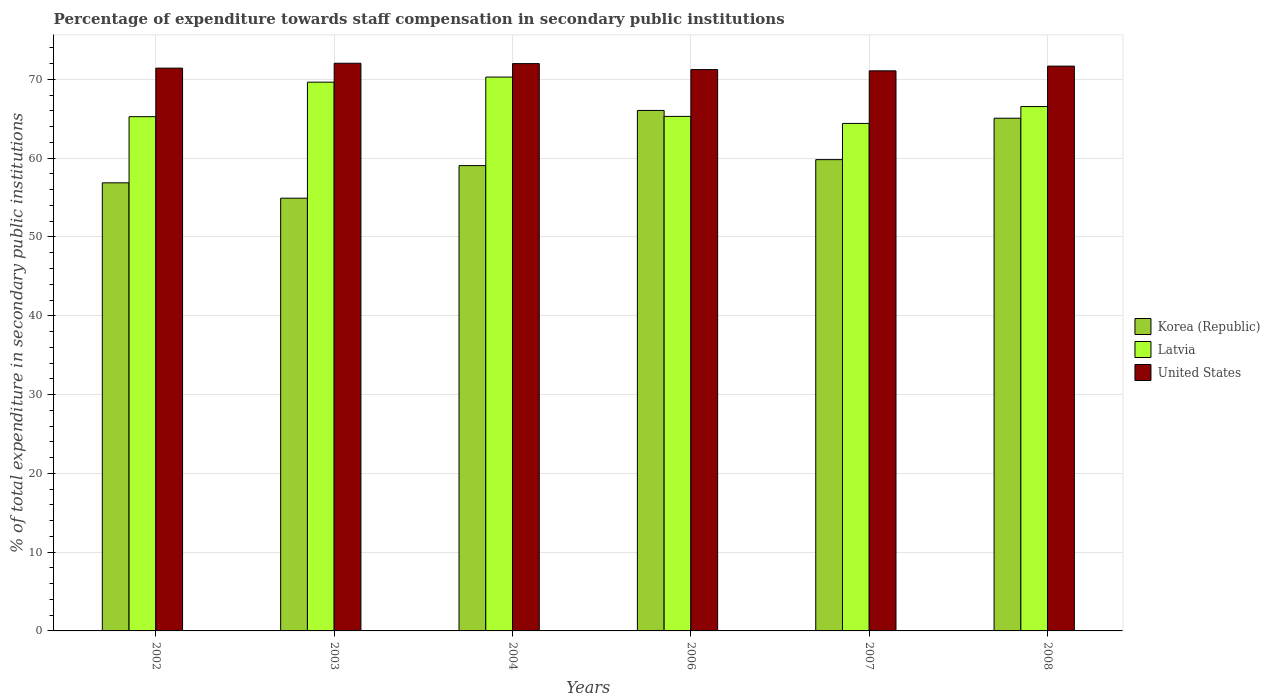How many groups of bars are there?
Provide a short and direct response. 6. Are the number of bars on each tick of the X-axis equal?
Provide a short and direct response. Yes. What is the label of the 3rd group of bars from the left?
Your answer should be very brief. 2004. What is the percentage of expenditure towards staff compensation in Latvia in 2002?
Make the answer very short. 65.27. Across all years, what is the maximum percentage of expenditure towards staff compensation in Korea (Republic)?
Your answer should be compact. 66.06. Across all years, what is the minimum percentage of expenditure towards staff compensation in Latvia?
Offer a very short reply. 64.41. What is the total percentage of expenditure towards staff compensation in Korea (Republic) in the graph?
Provide a succinct answer. 361.82. What is the difference between the percentage of expenditure towards staff compensation in Korea (Republic) in 2003 and that in 2004?
Ensure brevity in your answer.  -4.14. What is the difference between the percentage of expenditure towards staff compensation in United States in 2007 and the percentage of expenditure towards staff compensation in Latvia in 2003?
Give a very brief answer. 1.44. What is the average percentage of expenditure towards staff compensation in Latvia per year?
Provide a succinct answer. 66.92. In the year 2002, what is the difference between the percentage of expenditure towards staff compensation in Latvia and percentage of expenditure towards staff compensation in United States?
Provide a short and direct response. -6.16. What is the ratio of the percentage of expenditure towards staff compensation in Latvia in 2004 to that in 2008?
Your answer should be very brief. 1.06. Is the percentage of expenditure towards staff compensation in Latvia in 2004 less than that in 2007?
Your answer should be very brief. No. What is the difference between the highest and the second highest percentage of expenditure towards staff compensation in United States?
Provide a succinct answer. 0.04. What is the difference between the highest and the lowest percentage of expenditure towards staff compensation in Latvia?
Your response must be concise. 5.88. In how many years, is the percentage of expenditure towards staff compensation in Latvia greater than the average percentage of expenditure towards staff compensation in Latvia taken over all years?
Provide a short and direct response. 2. What does the 3rd bar from the right in 2008 represents?
Your answer should be compact. Korea (Republic). Is it the case that in every year, the sum of the percentage of expenditure towards staff compensation in United States and percentage of expenditure towards staff compensation in Korea (Republic) is greater than the percentage of expenditure towards staff compensation in Latvia?
Keep it short and to the point. Yes. Are the values on the major ticks of Y-axis written in scientific E-notation?
Your response must be concise. No. How many legend labels are there?
Your response must be concise. 3. How are the legend labels stacked?
Your response must be concise. Vertical. What is the title of the graph?
Your response must be concise. Percentage of expenditure towards staff compensation in secondary public institutions. Does "China" appear as one of the legend labels in the graph?
Offer a terse response. No. What is the label or title of the Y-axis?
Your response must be concise. % of total expenditure in secondary public institutions. What is the % of total expenditure in secondary public institutions in Korea (Republic) in 2002?
Keep it short and to the point. 56.87. What is the % of total expenditure in secondary public institutions of Latvia in 2002?
Provide a succinct answer. 65.27. What is the % of total expenditure in secondary public institutions in United States in 2002?
Provide a short and direct response. 71.43. What is the % of total expenditure in secondary public institutions in Korea (Republic) in 2003?
Keep it short and to the point. 54.92. What is the % of total expenditure in secondary public institutions of Latvia in 2003?
Provide a succinct answer. 69.65. What is the % of total expenditure in secondary public institutions in United States in 2003?
Make the answer very short. 72.05. What is the % of total expenditure in secondary public institutions of Korea (Republic) in 2004?
Provide a short and direct response. 59.06. What is the % of total expenditure in secondary public institutions in Latvia in 2004?
Your answer should be compact. 70.3. What is the % of total expenditure in secondary public institutions of United States in 2004?
Your answer should be compact. 72.01. What is the % of total expenditure in secondary public institutions of Korea (Republic) in 2006?
Ensure brevity in your answer.  66.06. What is the % of total expenditure in secondary public institutions in Latvia in 2006?
Your answer should be very brief. 65.31. What is the % of total expenditure in secondary public institutions of United States in 2006?
Your response must be concise. 71.25. What is the % of total expenditure in secondary public institutions of Korea (Republic) in 2007?
Offer a terse response. 59.82. What is the % of total expenditure in secondary public institutions of Latvia in 2007?
Your answer should be compact. 64.41. What is the % of total expenditure in secondary public institutions of United States in 2007?
Provide a succinct answer. 71.09. What is the % of total expenditure in secondary public institutions of Korea (Republic) in 2008?
Provide a succinct answer. 65.08. What is the % of total expenditure in secondary public institutions in Latvia in 2008?
Provide a succinct answer. 66.56. What is the % of total expenditure in secondary public institutions in United States in 2008?
Give a very brief answer. 71.69. Across all years, what is the maximum % of total expenditure in secondary public institutions in Korea (Republic)?
Provide a succinct answer. 66.06. Across all years, what is the maximum % of total expenditure in secondary public institutions in Latvia?
Keep it short and to the point. 70.3. Across all years, what is the maximum % of total expenditure in secondary public institutions of United States?
Offer a very short reply. 72.05. Across all years, what is the minimum % of total expenditure in secondary public institutions in Korea (Republic)?
Provide a short and direct response. 54.92. Across all years, what is the minimum % of total expenditure in secondary public institutions of Latvia?
Provide a succinct answer. 64.41. Across all years, what is the minimum % of total expenditure in secondary public institutions of United States?
Offer a terse response. 71.09. What is the total % of total expenditure in secondary public institutions in Korea (Republic) in the graph?
Your response must be concise. 361.82. What is the total % of total expenditure in secondary public institutions of Latvia in the graph?
Your answer should be compact. 401.49. What is the total % of total expenditure in secondary public institutions in United States in the graph?
Your response must be concise. 429.51. What is the difference between the % of total expenditure in secondary public institutions in Korea (Republic) in 2002 and that in 2003?
Ensure brevity in your answer.  1.95. What is the difference between the % of total expenditure in secondary public institutions of Latvia in 2002 and that in 2003?
Make the answer very short. -4.38. What is the difference between the % of total expenditure in secondary public institutions of United States in 2002 and that in 2003?
Offer a terse response. -0.62. What is the difference between the % of total expenditure in secondary public institutions in Korea (Republic) in 2002 and that in 2004?
Give a very brief answer. -2.19. What is the difference between the % of total expenditure in secondary public institutions in Latvia in 2002 and that in 2004?
Offer a terse response. -5.03. What is the difference between the % of total expenditure in secondary public institutions of United States in 2002 and that in 2004?
Keep it short and to the point. -0.57. What is the difference between the % of total expenditure in secondary public institutions of Korea (Republic) in 2002 and that in 2006?
Your answer should be very brief. -9.19. What is the difference between the % of total expenditure in secondary public institutions of Latvia in 2002 and that in 2006?
Your response must be concise. -0.04. What is the difference between the % of total expenditure in secondary public institutions in United States in 2002 and that in 2006?
Provide a short and direct response. 0.18. What is the difference between the % of total expenditure in secondary public institutions of Korea (Republic) in 2002 and that in 2007?
Your answer should be compact. -2.94. What is the difference between the % of total expenditure in secondary public institutions of Latvia in 2002 and that in 2007?
Give a very brief answer. 0.86. What is the difference between the % of total expenditure in secondary public institutions of United States in 2002 and that in 2007?
Give a very brief answer. 0.34. What is the difference between the % of total expenditure in secondary public institutions of Korea (Republic) in 2002 and that in 2008?
Make the answer very short. -8.2. What is the difference between the % of total expenditure in secondary public institutions in Latvia in 2002 and that in 2008?
Keep it short and to the point. -1.29. What is the difference between the % of total expenditure in secondary public institutions in United States in 2002 and that in 2008?
Your answer should be compact. -0.26. What is the difference between the % of total expenditure in secondary public institutions of Korea (Republic) in 2003 and that in 2004?
Keep it short and to the point. -4.14. What is the difference between the % of total expenditure in secondary public institutions of Latvia in 2003 and that in 2004?
Give a very brief answer. -0.64. What is the difference between the % of total expenditure in secondary public institutions of United States in 2003 and that in 2004?
Your response must be concise. 0.04. What is the difference between the % of total expenditure in secondary public institutions of Korea (Republic) in 2003 and that in 2006?
Your answer should be very brief. -11.14. What is the difference between the % of total expenditure in secondary public institutions of Latvia in 2003 and that in 2006?
Offer a terse response. 4.35. What is the difference between the % of total expenditure in secondary public institutions of United States in 2003 and that in 2006?
Your answer should be compact. 0.8. What is the difference between the % of total expenditure in secondary public institutions of Korea (Republic) in 2003 and that in 2007?
Your answer should be very brief. -4.89. What is the difference between the % of total expenditure in secondary public institutions in Latvia in 2003 and that in 2007?
Make the answer very short. 5.24. What is the difference between the % of total expenditure in secondary public institutions of United States in 2003 and that in 2007?
Offer a terse response. 0.96. What is the difference between the % of total expenditure in secondary public institutions of Korea (Republic) in 2003 and that in 2008?
Your response must be concise. -10.15. What is the difference between the % of total expenditure in secondary public institutions in Latvia in 2003 and that in 2008?
Ensure brevity in your answer.  3.1. What is the difference between the % of total expenditure in secondary public institutions of United States in 2003 and that in 2008?
Your response must be concise. 0.36. What is the difference between the % of total expenditure in secondary public institutions of Korea (Republic) in 2004 and that in 2006?
Provide a short and direct response. -7. What is the difference between the % of total expenditure in secondary public institutions in Latvia in 2004 and that in 2006?
Make the answer very short. 4.99. What is the difference between the % of total expenditure in secondary public institutions in United States in 2004 and that in 2006?
Make the answer very short. 0.76. What is the difference between the % of total expenditure in secondary public institutions of Korea (Republic) in 2004 and that in 2007?
Ensure brevity in your answer.  -0.76. What is the difference between the % of total expenditure in secondary public institutions of Latvia in 2004 and that in 2007?
Your answer should be compact. 5.88. What is the difference between the % of total expenditure in secondary public institutions of United States in 2004 and that in 2007?
Ensure brevity in your answer.  0.92. What is the difference between the % of total expenditure in secondary public institutions of Korea (Republic) in 2004 and that in 2008?
Your response must be concise. -6.02. What is the difference between the % of total expenditure in secondary public institutions of Latvia in 2004 and that in 2008?
Give a very brief answer. 3.74. What is the difference between the % of total expenditure in secondary public institutions in United States in 2004 and that in 2008?
Provide a short and direct response. 0.32. What is the difference between the % of total expenditure in secondary public institutions of Korea (Republic) in 2006 and that in 2007?
Ensure brevity in your answer.  6.24. What is the difference between the % of total expenditure in secondary public institutions of Latvia in 2006 and that in 2007?
Your response must be concise. 0.89. What is the difference between the % of total expenditure in secondary public institutions in United States in 2006 and that in 2007?
Your response must be concise. 0.16. What is the difference between the % of total expenditure in secondary public institutions of Korea (Republic) in 2006 and that in 2008?
Your answer should be compact. 0.98. What is the difference between the % of total expenditure in secondary public institutions in Latvia in 2006 and that in 2008?
Ensure brevity in your answer.  -1.25. What is the difference between the % of total expenditure in secondary public institutions of United States in 2006 and that in 2008?
Keep it short and to the point. -0.44. What is the difference between the % of total expenditure in secondary public institutions in Korea (Republic) in 2007 and that in 2008?
Ensure brevity in your answer.  -5.26. What is the difference between the % of total expenditure in secondary public institutions in Latvia in 2007 and that in 2008?
Provide a succinct answer. -2.14. What is the difference between the % of total expenditure in secondary public institutions of United States in 2007 and that in 2008?
Offer a very short reply. -0.6. What is the difference between the % of total expenditure in secondary public institutions of Korea (Republic) in 2002 and the % of total expenditure in secondary public institutions of Latvia in 2003?
Offer a terse response. -12.78. What is the difference between the % of total expenditure in secondary public institutions in Korea (Republic) in 2002 and the % of total expenditure in secondary public institutions in United States in 2003?
Make the answer very short. -15.18. What is the difference between the % of total expenditure in secondary public institutions of Latvia in 2002 and the % of total expenditure in secondary public institutions of United States in 2003?
Provide a short and direct response. -6.78. What is the difference between the % of total expenditure in secondary public institutions in Korea (Republic) in 2002 and the % of total expenditure in secondary public institutions in Latvia in 2004?
Keep it short and to the point. -13.42. What is the difference between the % of total expenditure in secondary public institutions in Korea (Republic) in 2002 and the % of total expenditure in secondary public institutions in United States in 2004?
Make the answer very short. -15.13. What is the difference between the % of total expenditure in secondary public institutions in Latvia in 2002 and the % of total expenditure in secondary public institutions in United States in 2004?
Keep it short and to the point. -6.74. What is the difference between the % of total expenditure in secondary public institutions in Korea (Republic) in 2002 and the % of total expenditure in secondary public institutions in Latvia in 2006?
Offer a terse response. -8.43. What is the difference between the % of total expenditure in secondary public institutions in Korea (Republic) in 2002 and the % of total expenditure in secondary public institutions in United States in 2006?
Make the answer very short. -14.37. What is the difference between the % of total expenditure in secondary public institutions in Latvia in 2002 and the % of total expenditure in secondary public institutions in United States in 2006?
Keep it short and to the point. -5.98. What is the difference between the % of total expenditure in secondary public institutions of Korea (Republic) in 2002 and the % of total expenditure in secondary public institutions of Latvia in 2007?
Keep it short and to the point. -7.54. What is the difference between the % of total expenditure in secondary public institutions of Korea (Republic) in 2002 and the % of total expenditure in secondary public institutions of United States in 2007?
Provide a succinct answer. -14.21. What is the difference between the % of total expenditure in secondary public institutions of Latvia in 2002 and the % of total expenditure in secondary public institutions of United States in 2007?
Your answer should be very brief. -5.82. What is the difference between the % of total expenditure in secondary public institutions in Korea (Republic) in 2002 and the % of total expenditure in secondary public institutions in Latvia in 2008?
Offer a very short reply. -9.68. What is the difference between the % of total expenditure in secondary public institutions in Korea (Republic) in 2002 and the % of total expenditure in secondary public institutions in United States in 2008?
Your answer should be compact. -14.81. What is the difference between the % of total expenditure in secondary public institutions in Latvia in 2002 and the % of total expenditure in secondary public institutions in United States in 2008?
Keep it short and to the point. -6.42. What is the difference between the % of total expenditure in secondary public institutions of Korea (Republic) in 2003 and the % of total expenditure in secondary public institutions of Latvia in 2004?
Offer a terse response. -15.37. What is the difference between the % of total expenditure in secondary public institutions of Korea (Republic) in 2003 and the % of total expenditure in secondary public institutions of United States in 2004?
Keep it short and to the point. -17.08. What is the difference between the % of total expenditure in secondary public institutions in Latvia in 2003 and the % of total expenditure in secondary public institutions in United States in 2004?
Your response must be concise. -2.35. What is the difference between the % of total expenditure in secondary public institutions in Korea (Republic) in 2003 and the % of total expenditure in secondary public institutions in Latvia in 2006?
Your answer should be very brief. -10.38. What is the difference between the % of total expenditure in secondary public institutions in Korea (Republic) in 2003 and the % of total expenditure in secondary public institutions in United States in 2006?
Your response must be concise. -16.32. What is the difference between the % of total expenditure in secondary public institutions in Latvia in 2003 and the % of total expenditure in secondary public institutions in United States in 2006?
Make the answer very short. -1.59. What is the difference between the % of total expenditure in secondary public institutions in Korea (Republic) in 2003 and the % of total expenditure in secondary public institutions in Latvia in 2007?
Provide a succinct answer. -9.49. What is the difference between the % of total expenditure in secondary public institutions in Korea (Republic) in 2003 and the % of total expenditure in secondary public institutions in United States in 2007?
Offer a terse response. -16.16. What is the difference between the % of total expenditure in secondary public institutions of Latvia in 2003 and the % of total expenditure in secondary public institutions of United States in 2007?
Offer a very short reply. -1.44. What is the difference between the % of total expenditure in secondary public institutions of Korea (Republic) in 2003 and the % of total expenditure in secondary public institutions of Latvia in 2008?
Make the answer very short. -11.63. What is the difference between the % of total expenditure in secondary public institutions of Korea (Republic) in 2003 and the % of total expenditure in secondary public institutions of United States in 2008?
Your response must be concise. -16.76. What is the difference between the % of total expenditure in secondary public institutions in Latvia in 2003 and the % of total expenditure in secondary public institutions in United States in 2008?
Offer a very short reply. -2.04. What is the difference between the % of total expenditure in secondary public institutions in Korea (Republic) in 2004 and the % of total expenditure in secondary public institutions in Latvia in 2006?
Keep it short and to the point. -6.25. What is the difference between the % of total expenditure in secondary public institutions in Korea (Republic) in 2004 and the % of total expenditure in secondary public institutions in United States in 2006?
Offer a terse response. -12.19. What is the difference between the % of total expenditure in secondary public institutions of Latvia in 2004 and the % of total expenditure in secondary public institutions of United States in 2006?
Provide a succinct answer. -0.95. What is the difference between the % of total expenditure in secondary public institutions in Korea (Republic) in 2004 and the % of total expenditure in secondary public institutions in Latvia in 2007?
Keep it short and to the point. -5.35. What is the difference between the % of total expenditure in secondary public institutions in Korea (Republic) in 2004 and the % of total expenditure in secondary public institutions in United States in 2007?
Make the answer very short. -12.03. What is the difference between the % of total expenditure in secondary public institutions of Latvia in 2004 and the % of total expenditure in secondary public institutions of United States in 2007?
Offer a terse response. -0.79. What is the difference between the % of total expenditure in secondary public institutions in Korea (Republic) in 2004 and the % of total expenditure in secondary public institutions in Latvia in 2008?
Provide a short and direct response. -7.49. What is the difference between the % of total expenditure in secondary public institutions of Korea (Republic) in 2004 and the % of total expenditure in secondary public institutions of United States in 2008?
Offer a terse response. -12.63. What is the difference between the % of total expenditure in secondary public institutions in Latvia in 2004 and the % of total expenditure in secondary public institutions in United States in 2008?
Your response must be concise. -1.39. What is the difference between the % of total expenditure in secondary public institutions of Korea (Republic) in 2006 and the % of total expenditure in secondary public institutions of Latvia in 2007?
Ensure brevity in your answer.  1.65. What is the difference between the % of total expenditure in secondary public institutions in Korea (Republic) in 2006 and the % of total expenditure in secondary public institutions in United States in 2007?
Provide a short and direct response. -5.03. What is the difference between the % of total expenditure in secondary public institutions of Latvia in 2006 and the % of total expenditure in secondary public institutions of United States in 2007?
Your answer should be very brief. -5.78. What is the difference between the % of total expenditure in secondary public institutions of Korea (Republic) in 2006 and the % of total expenditure in secondary public institutions of Latvia in 2008?
Provide a succinct answer. -0.49. What is the difference between the % of total expenditure in secondary public institutions of Korea (Republic) in 2006 and the % of total expenditure in secondary public institutions of United States in 2008?
Your answer should be compact. -5.63. What is the difference between the % of total expenditure in secondary public institutions in Latvia in 2006 and the % of total expenditure in secondary public institutions in United States in 2008?
Provide a short and direct response. -6.38. What is the difference between the % of total expenditure in secondary public institutions in Korea (Republic) in 2007 and the % of total expenditure in secondary public institutions in Latvia in 2008?
Make the answer very short. -6.74. What is the difference between the % of total expenditure in secondary public institutions in Korea (Republic) in 2007 and the % of total expenditure in secondary public institutions in United States in 2008?
Your answer should be very brief. -11.87. What is the difference between the % of total expenditure in secondary public institutions of Latvia in 2007 and the % of total expenditure in secondary public institutions of United States in 2008?
Your answer should be very brief. -7.27. What is the average % of total expenditure in secondary public institutions in Korea (Republic) per year?
Offer a very short reply. 60.3. What is the average % of total expenditure in secondary public institutions of Latvia per year?
Give a very brief answer. 66.92. What is the average % of total expenditure in secondary public institutions of United States per year?
Offer a very short reply. 71.59. In the year 2002, what is the difference between the % of total expenditure in secondary public institutions of Korea (Republic) and % of total expenditure in secondary public institutions of Latvia?
Your answer should be very brief. -8.39. In the year 2002, what is the difference between the % of total expenditure in secondary public institutions of Korea (Republic) and % of total expenditure in secondary public institutions of United States?
Provide a succinct answer. -14.56. In the year 2002, what is the difference between the % of total expenditure in secondary public institutions of Latvia and % of total expenditure in secondary public institutions of United States?
Make the answer very short. -6.16. In the year 2003, what is the difference between the % of total expenditure in secondary public institutions in Korea (Republic) and % of total expenditure in secondary public institutions in Latvia?
Your answer should be compact. -14.73. In the year 2003, what is the difference between the % of total expenditure in secondary public institutions of Korea (Republic) and % of total expenditure in secondary public institutions of United States?
Your response must be concise. -17.13. In the year 2003, what is the difference between the % of total expenditure in secondary public institutions of Latvia and % of total expenditure in secondary public institutions of United States?
Give a very brief answer. -2.4. In the year 2004, what is the difference between the % of total expenditure in secondary public institutions of Korea (Republic) and % of total expenditure in secondary public institutions of Latvia?
Make the answer very short. -11.24. In the year 2004, what is the difference between the % of total expenditure in secondary public institutions of Korea (Republic) and % of total expenditure in secondary public institutions of United States?
Make the answer very short. -12.95. In the year 2004, what is the difference between the % of total expenditure in secondary public institutions in Latvia and % of total expenditure in secondary public institutions in United States?
Provide a short and direct response. -1.71. In the year 2006, what is the difference between the % of total expenditure in secondary public institutions in Korea (Republic) and % of total expenditure in secondary public institutions in Latvia?
Give a very brief answer. 0.76. In the year 2006, what is the difference between the % of total expenditure in secondary public institutions in Korea (Republic) and % of total expenditure in secondary public institutions in United States?
Ensure brevity in your answer.  -5.19. In the year 2006, what is the difference between the % of total expenditure in secondary public institutions of Latvia and % of total expenditure in secondary public institutions of United States?
Your response must be concise. -5.94. In the year 2007, what is the difference between the % of total expenditure in secondary public institutions in Korea (Republic) and % of total expenditure in secondary public institutions in Latvia?
Your response must be concise. -4.59. In the year 2007, what is the difference between the % of total expenditure in secondary public institutions of Korea (Republic) and % of total expenditure in secondary public institutions of United States?
Keep it short and to the point. -11.27. In the year 2007, what is the difference between the % of total expenditure in secondary public institutions of Latvia and % of total expenditure in secondary public institutions of United States?
Provide a succinct answer. -6.67. In the year 2008, what is the difference between the % of total expenditure in secondary public institutions in Korea (Republic) and % of total expenditure in secondary public institutions in Latvia?
Provide a short and direct response. -1.48. In the year 2008, what is the difference between the % of total expenditure in secondary public institutions in Korea (Republic) and % of total expenditure in secondary public institutions in United States?
Your answer should be very brief. -6.61. In the year 2008, what is the difference between the % of total expenditure in secondary public institutions of Latvia and % of total expenditure in secondary public institutions of United States?
Keep it short and to the point. -5.13. What is the ratio of the % of total expenditure in secondary public institutions of Korea (Republic) in 2002 to that in 2003?
Your response must be concise. 1.04. What is the ratio of the % of total expenditure in secondary public institutions in Latvia in 2002 to that in 2003?
Give a very brief answer. 0.94. What is the ratio of the % of total expenditure in secondary public institutions in United States in 2002 to that in 2003?
Keep it short and to the point. 0.99. What is the ratio of the % of total expenditure in secondary public institutions of Korea (Republic) in 2002 to that in 2004?
Offer a very short reply. 0.96. What is the ratio of the % of total expenditure in secondary public institutions of Latvia in 2002 to that in 2004?
Your answer should be very brief. 0.93. What is the ratio of the % of total expenditure in secondary public institutions in United States in 2002 to that in 2004?
Offer a terse response. 0.99. What is the ratio of the % of total expenditure in secondary public institutions in Korea (Republic) in 2002 to that in 2006?
Your answer should be compact. 0.86. What is the ratio of the % of total expenditure in secondary public institutions of Korea (Republic) in 2002 to that in 2007?
Provide a succinct answer. 0.95. What is the ratio of the % of total expenditure in secondary public institutions in Latvia in 2002 to that in 2007?
Provide a short and direct response. 1.01. What is the ratio of the % of total expenditure in secondary public institutions in United States in 2002 to that in 2007?
Provide a short and direct response. 1. What is the ratio of the % of total expenditure in secondary public institutions of Korea (Republic) in 2002 to that in 2008?
Your answer should be very brief. 0.87. What is the ratio of the % of total expenditure in secondary public institutions in Latvia in 2002 to that in 2008?
Provide a succinct answer. 0.98. What is the ratio of the % of total expenditure in secondary public institutions in Korea (Republic) in 2003 to that in 2006?
Your response must be concise. 0.83. What is the ratio of the % of total expenditure in secondary public institutions in Latvia in 2003 to that in 2006?
Provide a short and direct response. 1.07. What is the ratio of the % of total expenditure in secondary public institutions of United States in 2003 to that in 2006?
Your answer should be compact. 1.01. What is the ratio of the % of total expenditure in secondary public institutions in Korea (Republic) in 2003 to that in 2007?
Give a very brief answer. 0.92. What is the ratio of the % of total expenditure in secondary public institutions in Latvia in 2003 to that in 2007?
Your answer should be compact. 1.08. What is the ratio of the % of total expenditure in secondary public institutions in United States in 2003 to that in 2007?
Offer a terse response. 1.01. What is the ratio of the % of total expenditure in secondary public institutions of Korea (Republic) in 2003 to that in 2008?
Your response must be concise. 0.84. What is the ratio of the % of total expenditure in secondary public institutions in Latvia in 2003 to that in 2008?
Provide a short and direct response. 1.05. What is the ratio of the % of total expenditure in secondary public institutions of United States in 2003 to that in 2008?
Keep it short and to the point. 1.01. What is the ratio of the % of total expenditure in secondary public institutions of Korea (Republic) in 2004 to that in 2006?
Ensure brevity in your answer.  0.89. What is the ratio of the % of total expenditure in secondary public institutions of Latvia in 2004 to that in 2006?
Offer a very short reply. 1.08. What is the ratio of the % of total expenditure in secondary public institutions in United States in 2004 to that in 2006?
Ensure brevity in your answer.  1.01. What is the ratio of the % of total expenditure in secondary public institutions in Korea (Republic) in 2004 to that in 2007?
Your answer should be very brief. 0.99. What is the ratio of the % of total expenditure in secondary public institutions of Latvia in 2004 to that in 2007?
Your response must be concise. 1.09. What is the ratio of the % of total expenditure in secondary public institutions of United States in 2004 to that in 2007?
Give a very brief answer. 1.01. What is the ratio of the % of total expenditure in secondary public institutions of Korea (Republic) in 2004 to that in 2008?
Give a very brief answer. 0.91. What is the ratio of the % of total expenditure in secondary public institutions of Latvia in 2004 to that in 2008?
Give a very brief answer. 1.06. What is the ratio of the % of total expenditure in secondary public institutions of Korea (Republic) in 2006 to that in 2007?
Give a very brief answer. 1.1. What is the ratio of the % of total expenditure in secondary public institutions of Latvia in 2006 to that in 2007?
Offer a very short reply. 1.01. What is the ratio of the % of total expenditure in secondary public institutions in United States in 2006 to that in 2007?
Make the answer very short. 1. What is the ratio of the % of total expenditure in secondary public institutions of Korea (Republic) in 2006 to that in 2008?
Make the answer very short. 1.02. What is the ratio of the % of total expenditure in secondary public institutions of Latvia in 2006 to that in 2008?
Provide a short and direct response. 0.98. What is the ratio of the % of total expenditure in secondary public institutions of United States in 2006 to that in 2008?
Make the answer very short. 0.99. What is the ratio of the % of total expenditure in secondary public institutions in Korea (Republic) in 2007 to that in 2008?
Ensure brevity in your answer.  0.92. What is the ratio of the % of total expenditure in secondary public institutions in Latvia in 2007 to that in 2008?
Provide a short and direct response. 0.97. What is the ratio of the % of total expenditure in secondary public institutions in United States in 2007 to that in 2008?
Make the answer very short. 0.99. What is the difference between the highest and the second highest % of total expenditure in secondary public institutions in Korea (Republic)?
Your answer should be compact. 0.98. What is the difference between the highest and the second highest % of total expenditure in secondary public institutions of Latvia?
Ensure brevity in your answer.  0.64. What is the difference between the highest and the second highest % of total expenditure in secondary public institutions of United States?
Provide a succinct answer. 0.04. What is the difference between the highest and the lowest % of total expenditure in secondary public institutions of Korea (Republic)?
Offer a very short reply. 11.14. What is the difference between the highest and the lowest % of total expenditure in secondary public institutions of Latvia?
Keep it short and to the point. 5.88. What is the difference between the highest and the lowest % of total expenditure in secondary public institutions of United States?
Make the answer very short. 0.96. 